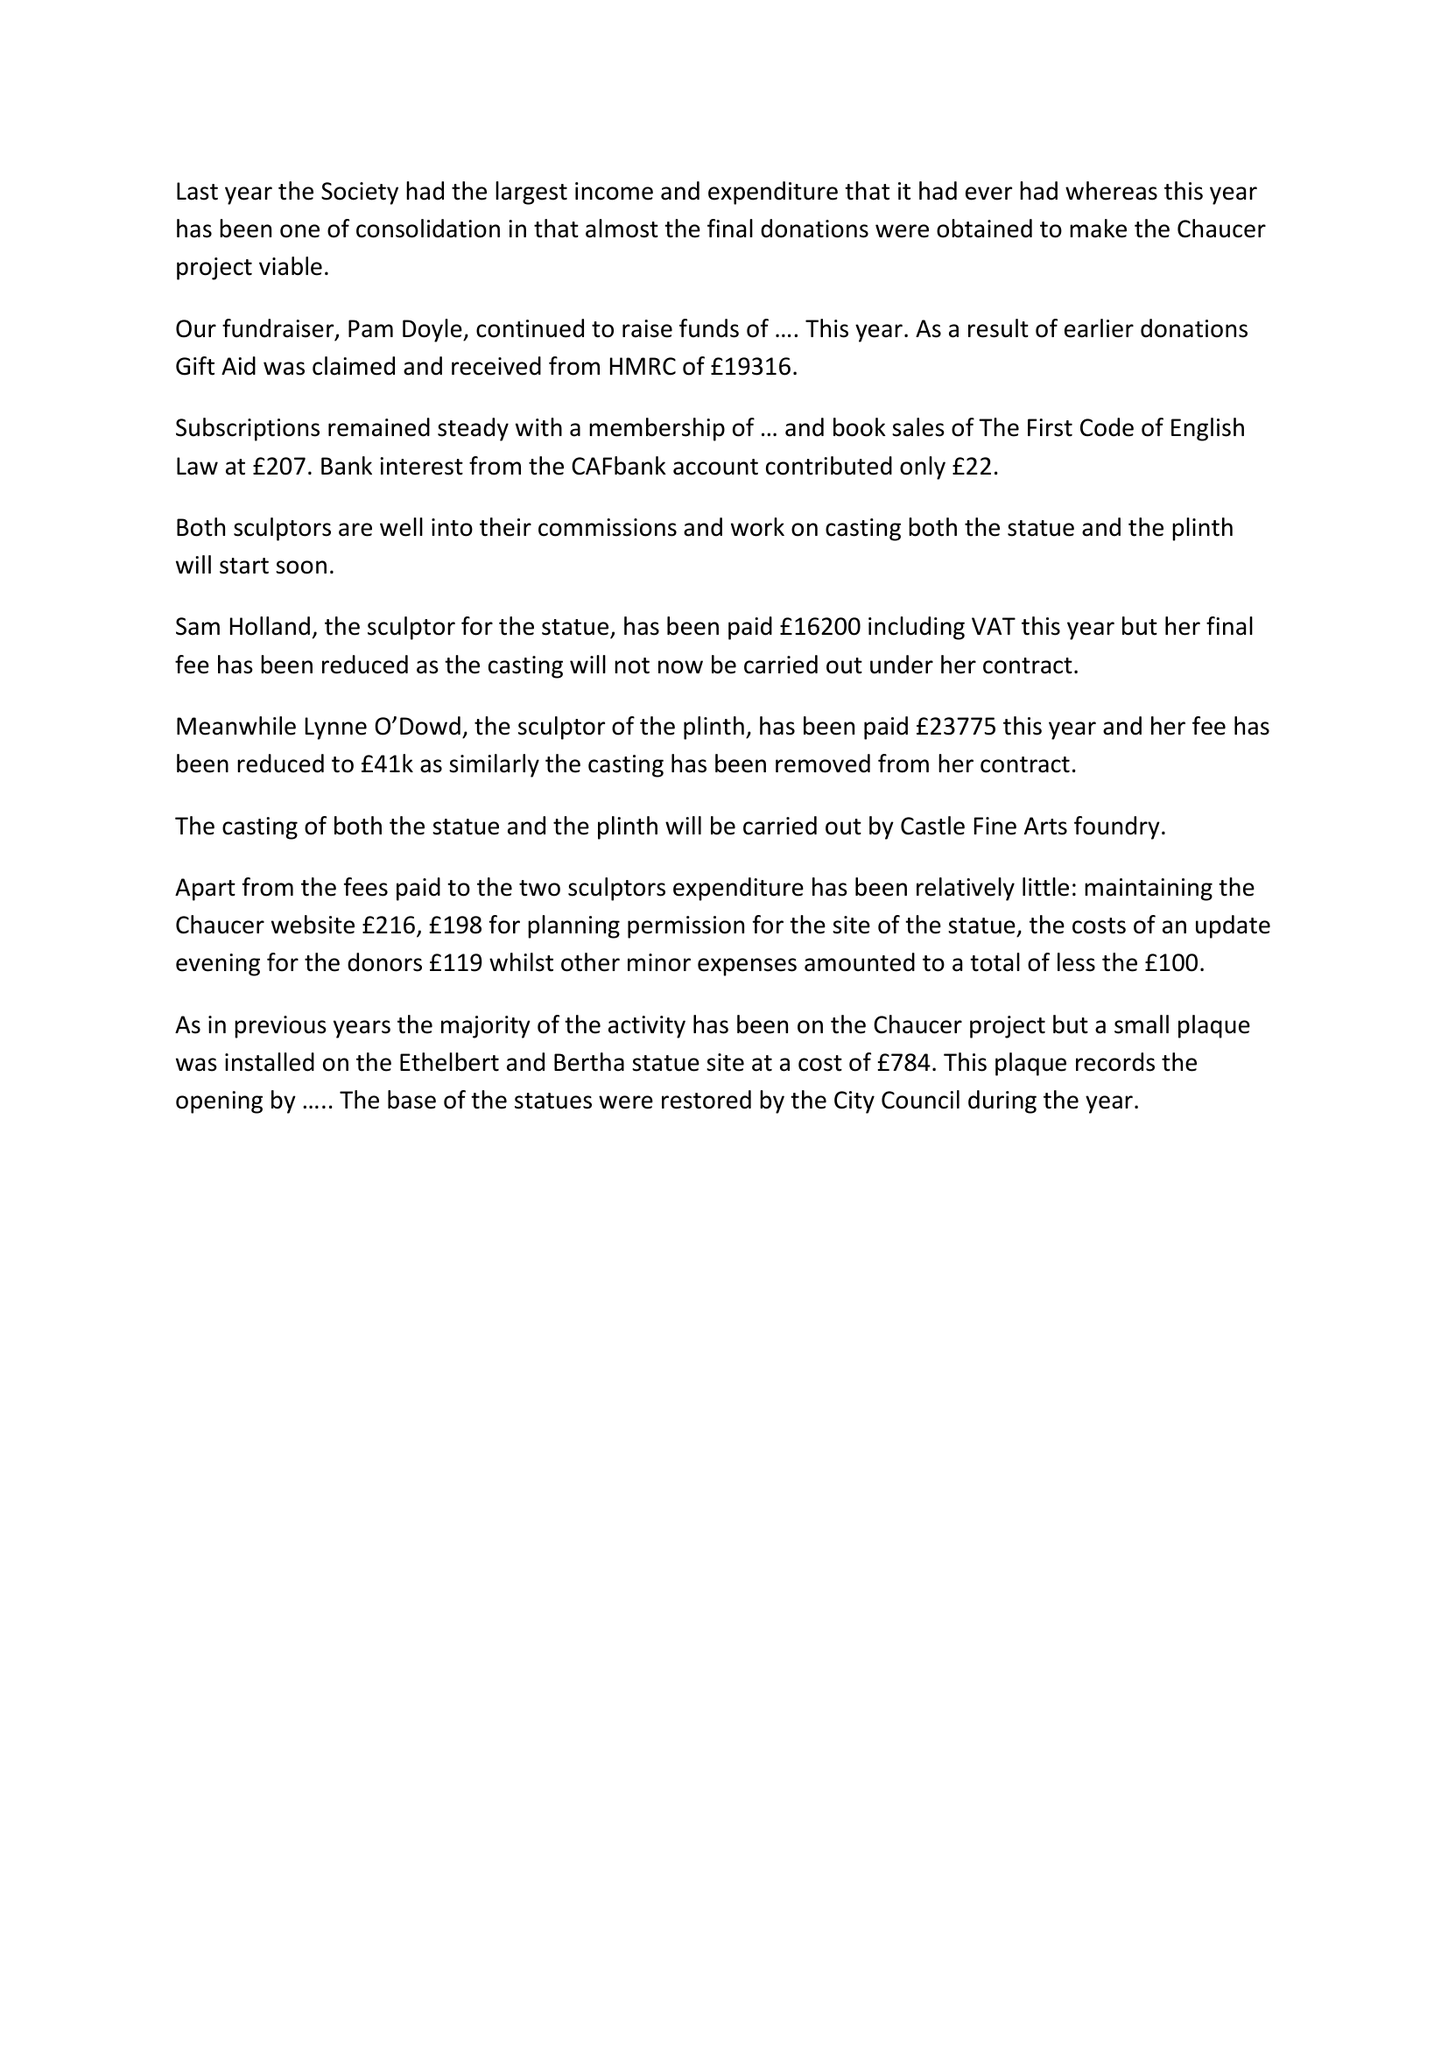What is the value for the address__street_line?
Answer the question using a single word or phrase. None 